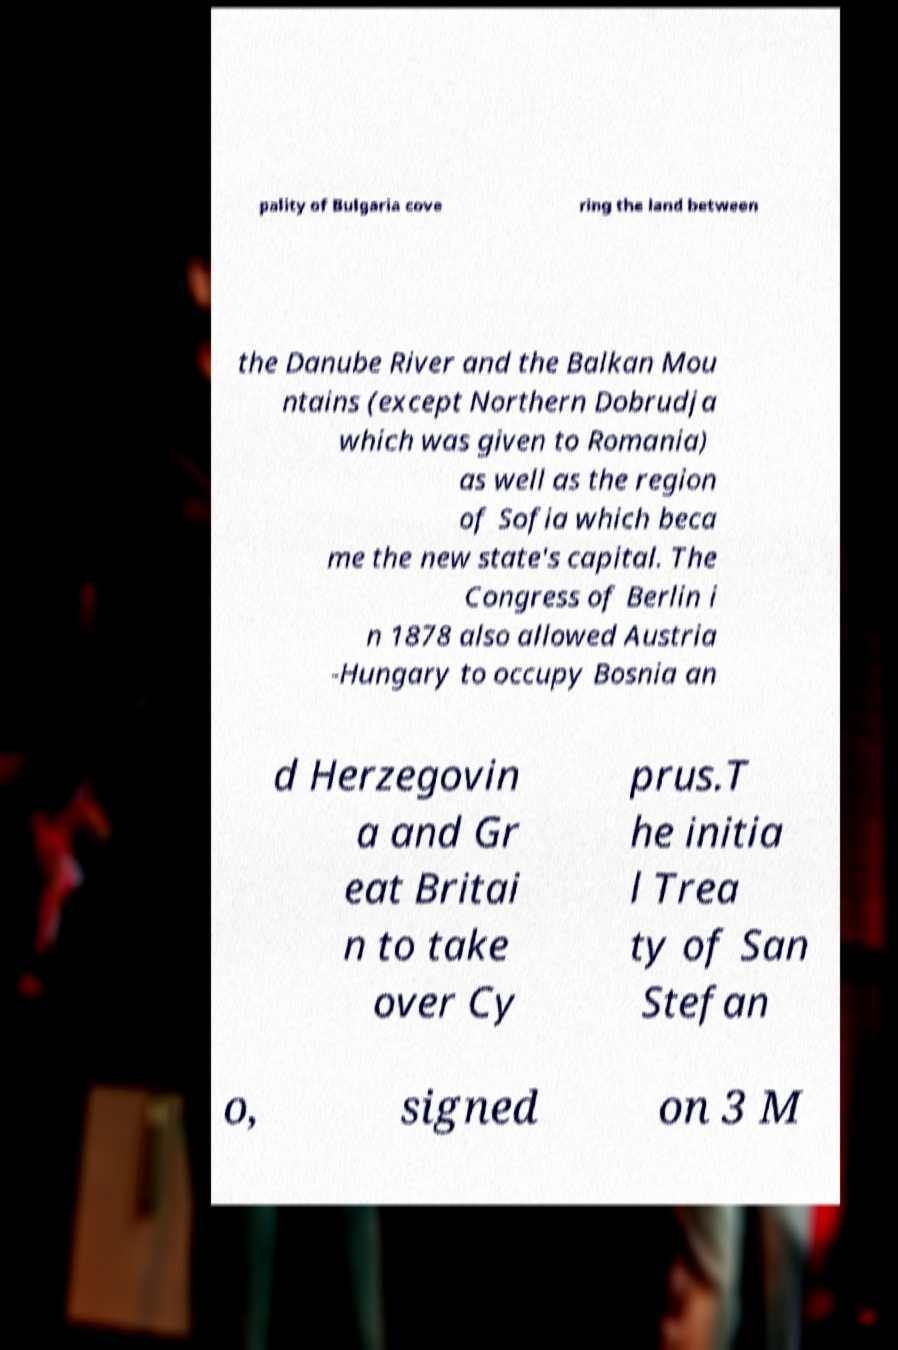Please read and relay the text visible in this image. What does it say? pality of Bulgaria cove ring the land between the Danube River and the Balkan Mou ntains (except Northern Dobrudja which was given to Romania) as well as the region of Sofia which beca me the new state's capital. The Congress of Berlin i n 1878 also allowed Austria -Hungary to occupy Bosnia an d Herzegovin a and Gr eat Britai n to take over Cy prus.T he initia l Trea ty of San Stefan o, signed on 3 M 